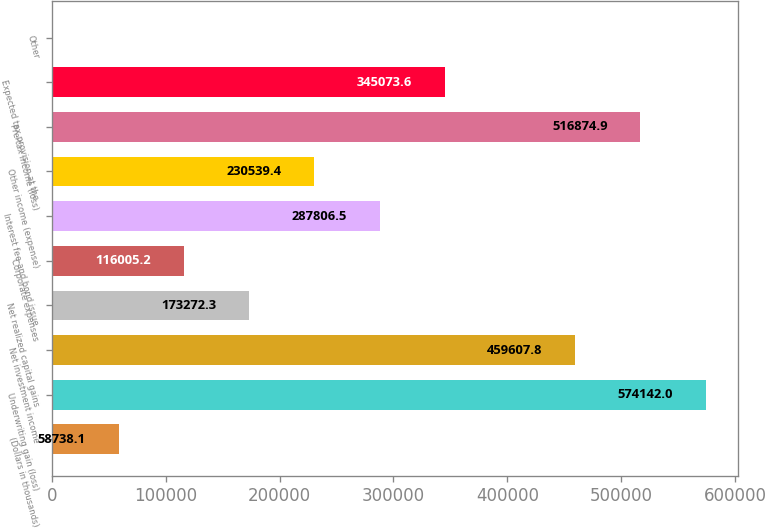Convert chart to OTSL. <chart><loc_0><loc_0><loc_500><loc_500><bar_chart><fcel>(Dollars in thousands)<fcel>Underwriting gain (loss)<fcel>Net investment income<fcel>Net realized capital gains<fcel>Corporate expenses<fcel>Interest fee and bond issue<fcel>Other income (expense)<fcel>Pre-tax income (loss)<fcel>Expected tax provision at the<fcel>Other<nl><fcel>58738.1<fcel>574142<fcel>459608<fcel>173272<fcel>116005<fcel>287806<fcel>230539<fcel>516875<fcel>345074<fcel>1471<nl></chart> 